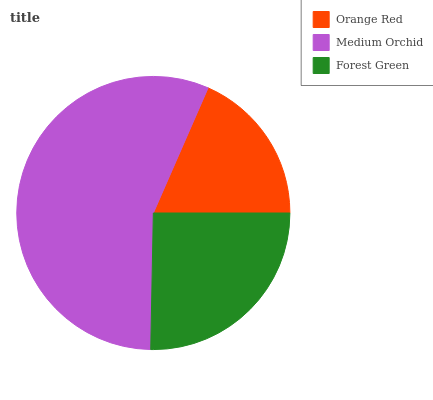Is Orange Red the minimum?
Answer yes or no. Yes. Is Medium Orchid the maximum?
Answer yes or no. Yes. Is Forest Green the minimum?
Answer yes or no. No. Is Forest Green the maximum?
Answer yes or no. No. Is Medium Orchid greater than Forest Green?
Answer yes or no. Yes. Is Forest Green less than Medium Orchid?
Answer yes or no. Yes. Is Forest Green greater than Medium Orchid?
Answer yes or no. No. Is Medium Orchid less than Forest Green?
Answer yes or no. No. Is Forest Green the high median?
Answer yes or no. Yes. Is Forest Green the low median?
Answer yes or no. Yes. Is Medium Orchid the high median?
Answer yes or no. No. Is Orange Red the low median?
Answer yes or no. No. 